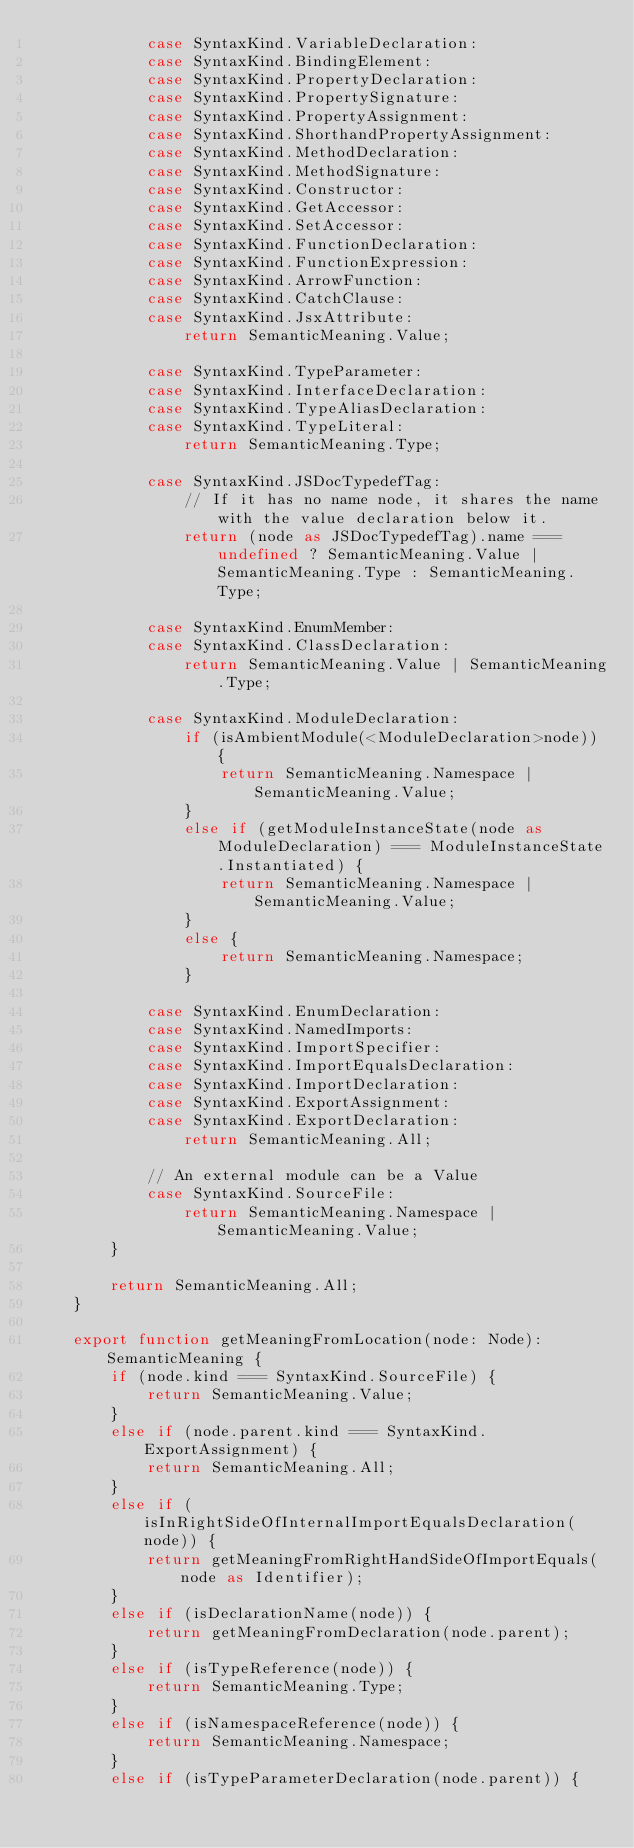<code> <loc_0><loc_0><loc_500><loc_500><_TypeScript_>            case SyntaxKind.VariableDeclaration:
            case SyntaxKind.BindingElement:
            case SyntaxKind.PropertyDeclaration:
            case SyntaxKind.PropertySignature:
            case SyntaxKind.PropertyAssignment:
            case SyntaxKind.ShorthandPropertyAssignment:
            case SyntaxKind.MethodDeclaration:
            case SyntaxKind.MethodSignature:
            case SyntaxKind.Constructor:
            case SyntaxKind.GetAccessor:
            case SyntaxKind.SetAccessor:
            case SyntaxKind.FunctionDeclaration:
            case SyntaxKind.FunctionExpression:
            case SyntaxKind.ArrowFunction:
            case SyntaxKind.CatchClause:
            case SyntaxKind.JsxAttribute:
                return SemanticMeaning.Value;

            case SyntaxKind.TypeParameter:
            case SyntaxKind.InterfaceDeclaration:
            case SyntaxKind.TypeAliasDeclaration:
            case SyntaxKind.TypeLiteral:
                return SemanticMeaning.Type;

            case SyntaxKind.JSDocTypedefTag:
                // If it has no name node, it shares the name with the value declaration below it.
                return (node as JSDocTypedefTag).name === undefined ? SemanticMeaning.Value | SemanticMeaning.Type : SemanticMeaning.Type;

            case SyntaxKind.EnumMember:
            case SyntaxKind.ClassDeclaration:
                return SemanticMeaning.Value | SemanticMeaning.Type;

            case SyntaxKind.ModuleDeclaration:
                if (isAmbientModule(<ModuleDeclaration>node)) {
                    return SemanticMeaning.Namespace | SemanticMeaning.Value;
                }
                else if (getModuleInstanceState(node as ModuleDeclaration) === ModuleInstanceState.Instantiated) {
                    return SemanticMeaning.Namespace | SemanticMeaning.Value;
                }
                else {
                    return SemanticMeaning.Namespace;
                }

            case SyntaxKind.EnumDeclaration:
            case SyntaxKind.NamedImports:
            case SyntaxKind.ImportSpecifier:
            case SyntaxKind.ImportEqualsDeclaration:
            case SyntaxKind.ImportDeclaration:
            case SyntaxKind.ExportAssignment:
            case SyntaxKind.ExportDeclaration:
                return SemanticMeaning.All;

            // An external module can be a Value
            case SyntaxKind.SourceFile:
                return SemanticMeaning.Namespace | SemanticMeaning.Value;
        }

        return SemanticMeaning.All;
    }

    export function getMeaningFromLocation(node: Node): SemanticMeaning {
        if (node.kind === SyntaxKind.SourceFile) {
            return SemanticMeaning.Value;
        }
        else if (node.parent.kind === SyntaxKind.ExportAssignment) {
            return SemanticMeaning.All;
        }
        else if (isInRightSideOfInternalImportEqualsDeclaration(node)) {
            return getMeaningFromRightHandSideOfImportEquals(node as Identifier);
        }
        else if (isDeclarationName(node)) {
            return getMeaningFromDeclaration(node.parent);
        }
        else if (isTypeReference(node)) {
            return SemanticMeaning.Type;
        }
        else if (isNamespaceReference(node)) {
            return SemanticMeaning.Namespace;
        }
        else if (isTypeParameterDeclaration(node.parent)) {</code> 